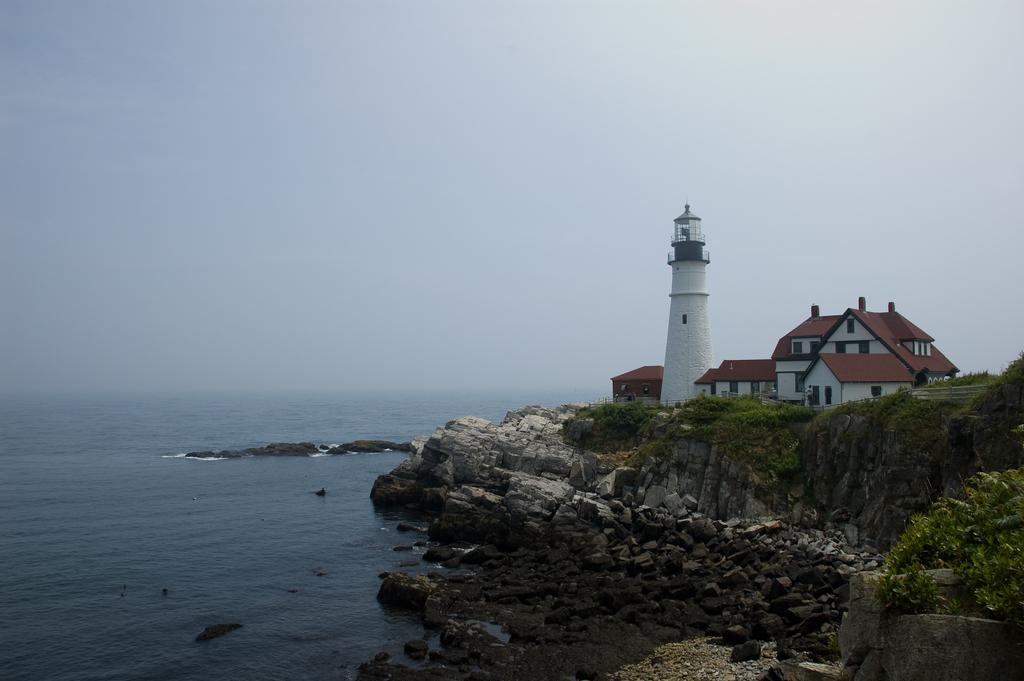What type of structures can be seen in the image? There are houses and a tower in the image. What natural elements are present in the image? There are rocks and plants in the image. What is the water source visible in the image? There is water visible in the image. What part of the natural environment can be seen in the background of the image? The sky is visible in the background of the image. What type of teeth can be seen in the image? There are no teeth visible in the image. How are the rocks sorted in the image? The rocks are not sorted in the image; they are simply present among other elements. 